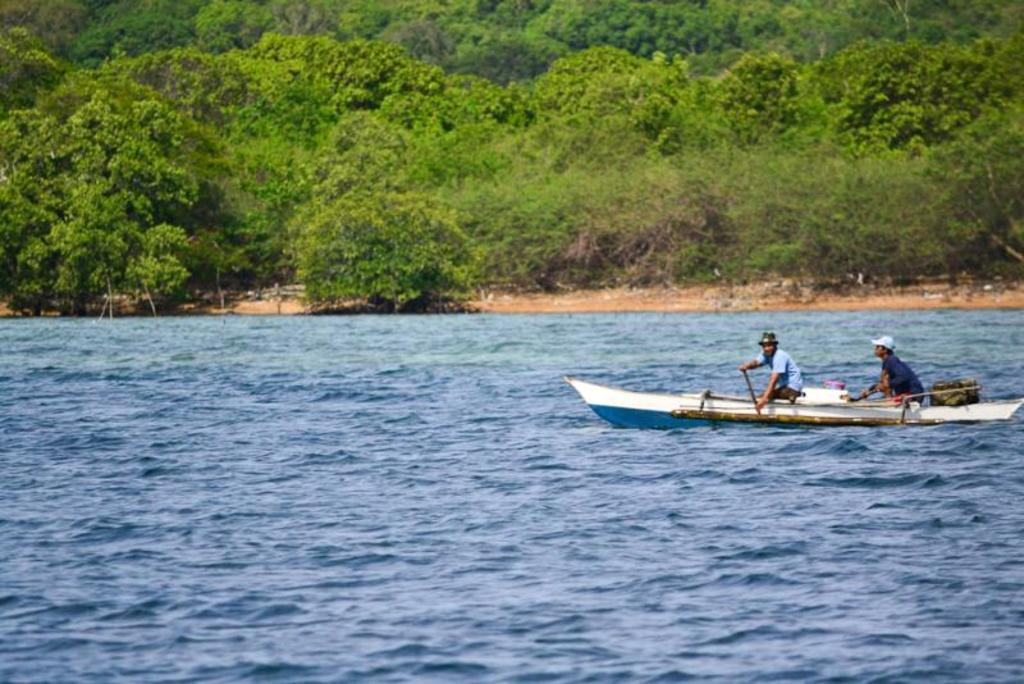What is the main subject of the image? The main subject of the image is a boat in the water. What color is the boat? The boat is blue and white in color. Are there any people on the boat? Yes, there are persons on the boat. What can be seen in the background of the image? In the background of the image, there is ground and trees visible. What type of work is the turkey doing on the boat in the image? There is no turkey present in the image, so it cannot determine any work it might be doing. 